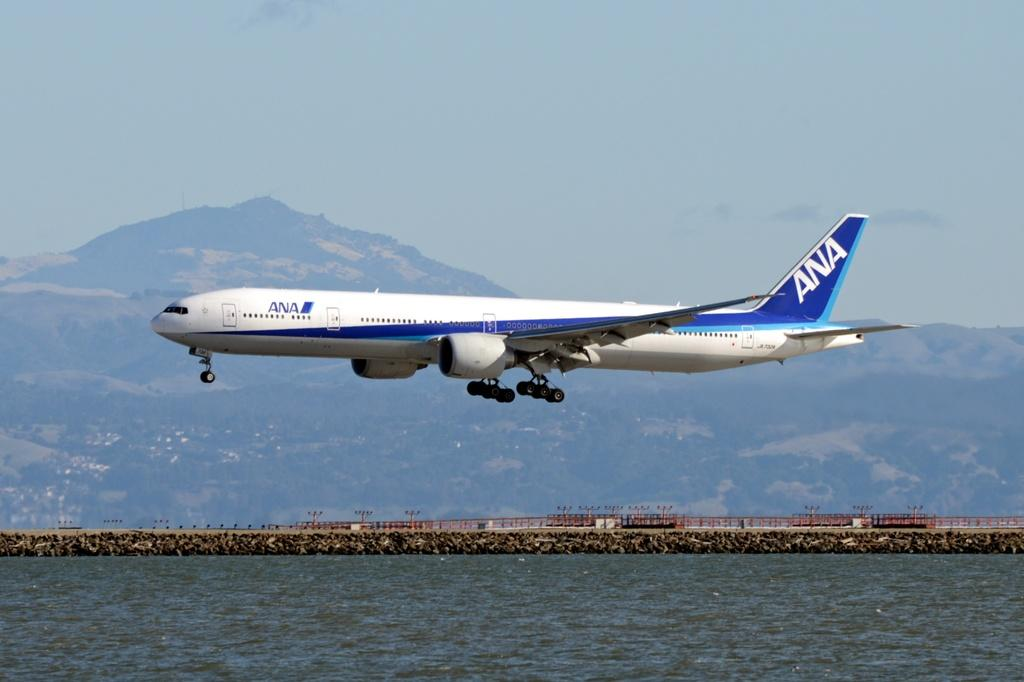<image>
Relay a brief, clear account of the picture shown. An ANA aeroplane flying very low over water 